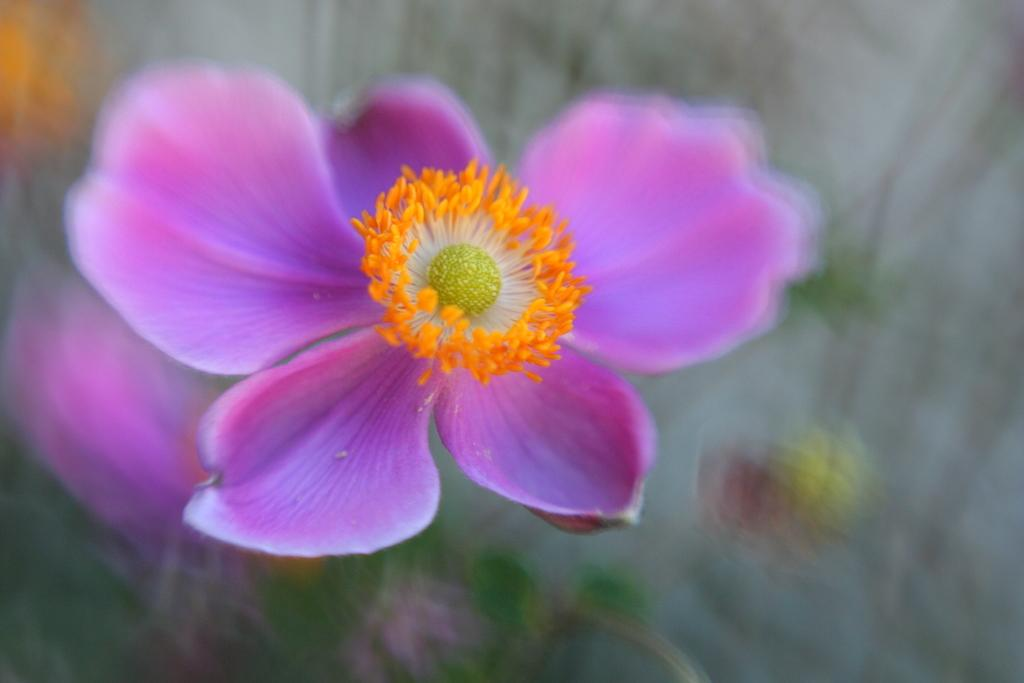What is the main subject of the image? There is a flower in the image. What is the color of the flower? The flower is purple in color. Can you describe the background of the image? The background of the image is blurred. What type of headwear is the flower wearing in the image? There is no headwear present in the image, as it features a flower. Is the flower playing baseball in the image? There is no baseball or any indication of a sport being played in the image. --- 